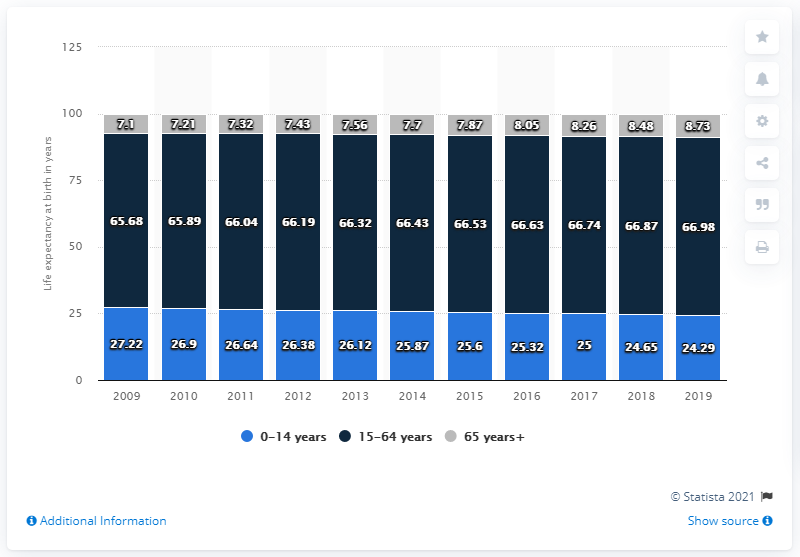Draw attention to some important aspects in this diagram. The age structure of children aged 0-14 in the year 2009 and 2019 was 51.51%. In 2019, approximately 24.29% of Turkey's population was aged between 0 and 14 years old. The age structure of 15-64 years has the highest number. 